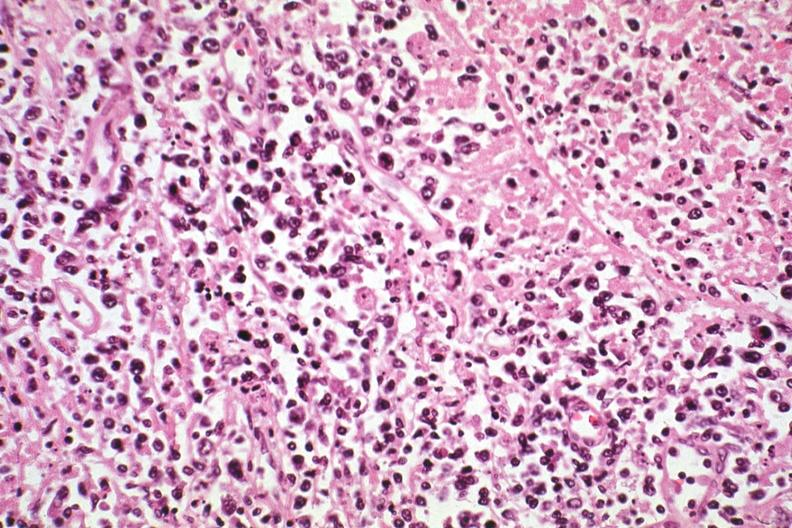s lymph node present?
Answer the question using a single word or phrase. Yes 